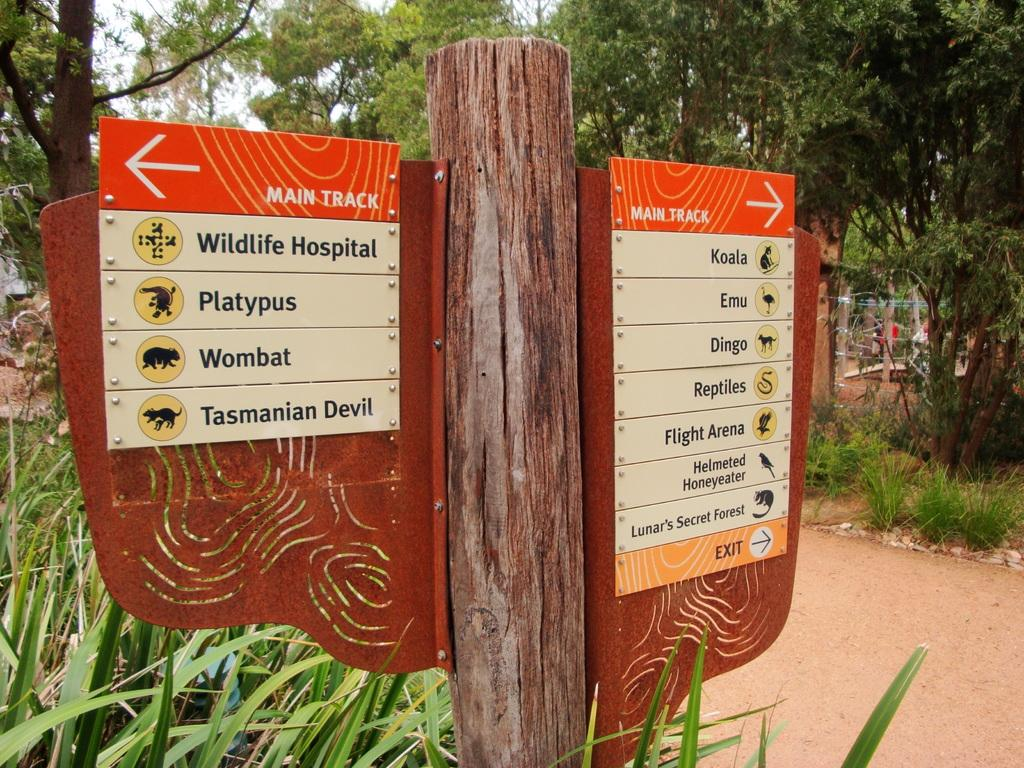What is located in the foreground of the image? There is a board in the foreground of the image. What can be seen in the background of the image? There are trees and plants in the background of the image. What is the purpose of the boundary in the image? The boundary in the image separates or defines a specific area. What is written or depicted on the board? There are texts and pictures of animals on the board. What type of destruction can be seen happening to the oven in the image? There is no oven present in the image, so it is not possible to determine if any destruction is occurring. 